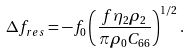<formula> <loc_0><loc_0><loc_500><loc_500>\Delta f _ { r e s } = - f _ { 0 } \left ( \frac { f \eta _ { 2 } \rho _ { 2 } } { \pi \rho _ { 0 } C _ { 6 6 } } \right ) ^ { 1 / 2 } .</formula> 